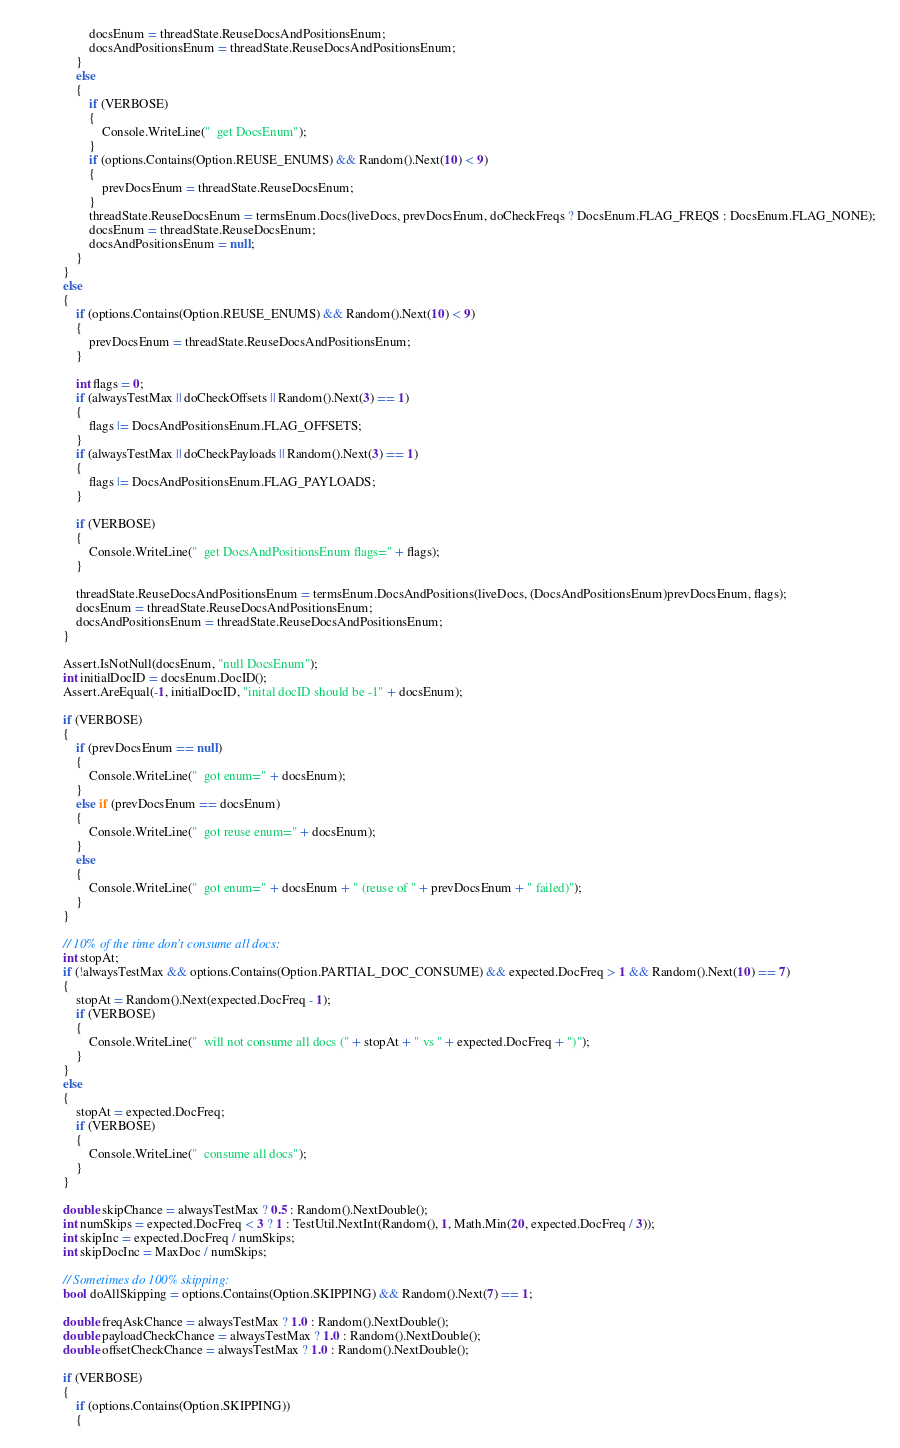<code> <loc_0><loc_0><loc_500><loc_500><_C#_>                    docsEnum = threadState.ReuseDocsAndPositionsEnum;
                    docsAndPositionsEnum = threadState.ReuseDocsAndPositionsEnum;
                }
                else
                {
                    if (VERBOSE)
                    {
                        Console.WriteLine("  get DocsEnum");
                    }
                    if (options.Contains(Option.REUSE_ENUMS) && Random().Next(10) < 9)
                    {
                        prevDocsEnum = threadState.ReuseDocsEnum;
                    }
                    threadState.ReuseDocsEnum = termsEnum.Docs(liveDocs, prevDocsEnum, doCheckFreqs ? DocsEnum.FLAG_FREQS : DocsEnum.FLAG_NONE);
                    docsEnum = threadState.ReuseDocsEnum;
                    docsAndPositionsEnum = null;
                }
            }
            else
            {
                if (options.Contains(Option.REUSE_ENUMS) && Random().Next(10) < 9)
                {
                    prevDocsEnum = threadState.ReuseDocsAndPositionsEnum;
                }

                int flags = 0;
                if (alwaysTestMax || doCheckOffsets || Random().Next(3) == 1)
                {
                    flags |= DocsAndPositionsEnum.FLAG_OFFSETS;
                }
                if (alwaysTestMax || doCheckPayloads || Random().Next(3) == 1)
                {
                    flags |= DocsAndPositionsEnum.FLAG_PAYLOADS;
                }

                if (VERBOSE)
                {
                    Console.WriteLine("  get DocsAndPositionsEnum flags=" + flags);
                }

                threadState.ReuseDocsAndPositionsEnum = termsEnum.DocsAndPositions(liveDocs, (DocsAndPositionsEnum)prevDocsEnum, flags);
                docsEnum = threadState.ReuseDocsAndPositionsEnum;
                docsAndPositionsEnum = threadState.ReuseDocsAndPositionsEnum;
            }

            Assert.IsNotNull(docsEnum, "null DocsEnum");
            int initialDocID = docsEnum.DocID();
            Assert.AreEqual(-1, initialDocID, "inital docID should be -1" + docsEnum);

            if (VERBOSE)
            {
                if (prevDocsEnum == null)
                {
                    Console.WriteLine("  got enum=" + docsEnum);
                }
                else if (prevDocsEnum == docsEnum)
                {
                    Console.WriteLine("  got reuse enum=" + docsEnum);
                }
                else
                {
                    Console.WriteLine("  got enum=" + docsEnum + " (reuse of " + prevDocsEnum + " failed)");
                }
            }

            // 10% of the time don't consume all docs:
            int stopAt;
            if (!alwaysTestMax && options.Contains(Option.PARTIAL_DOC_CONSUME) && expected.DocFreq > 1 && Random().Next(10) == 7)
            {
                stopAt = Random().Next(expected.DocFreq - 1);
                if (VERBOSE)
                {
                    Console.WriteLine("  will not consume all docs (" + stopAt + " vs " + expected.DocFreq + ")");
                }
            }
            else
            {
                stopAt = expected.DocFreq;
                if (VERBOSE)
                {
                    Console.WriteLine("  consume all docs");
                }
            }

            double skipChance = alwaysTestMax ? 0.5 : Random().NextDouble();
            int numSkips = expected.DocFreq < 3 ? 1 : TestUtil.NextInt(Random(), 1, Math.Min(20, expected.DocFreq / 3));
            int skipInc = expected.DocFreq / numSkips;
            int skipDocInc = MaxDoc / numSkips;

            // Sometimes do 100% skipping:
            bool doAllSkipping = options.Contains(Option.SKIPPING) && Random().Next(7) == 1;

            double freqAskChance = alwaysTestMax ? 1.0 : Random().NextDouble();
            double payloadCheckChance = alwaysTestMax ? 1.0 : Random().NextDouble();
            double offsetCheckChance = alwaysTestMax ? 1.0 : Random().NextDouble();

            if (VERBOSE)
            {
                if (options.Contains(Option.SKIPPING))
                {</code> 